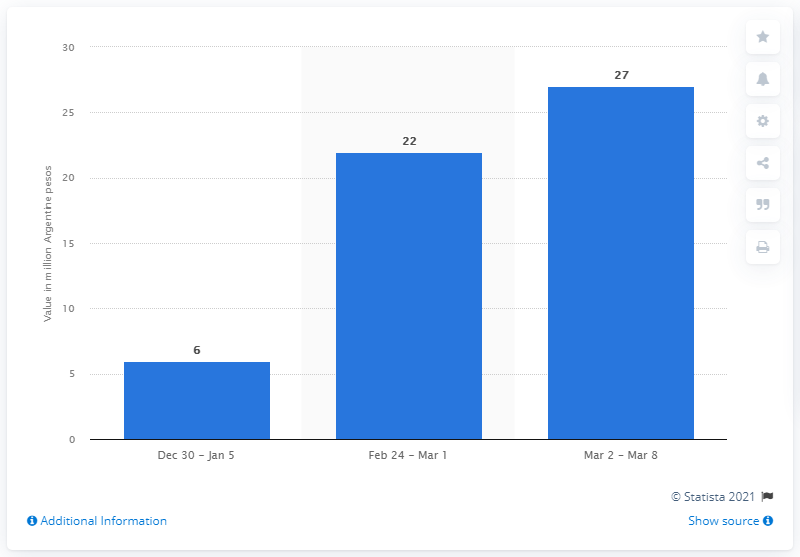Specify some key components in this picture. Sales of alcohol-based hand sanitizers in the ninth week of the same year in Argentina were 22. The sales value of antibacterial gel the following week was 27.. 